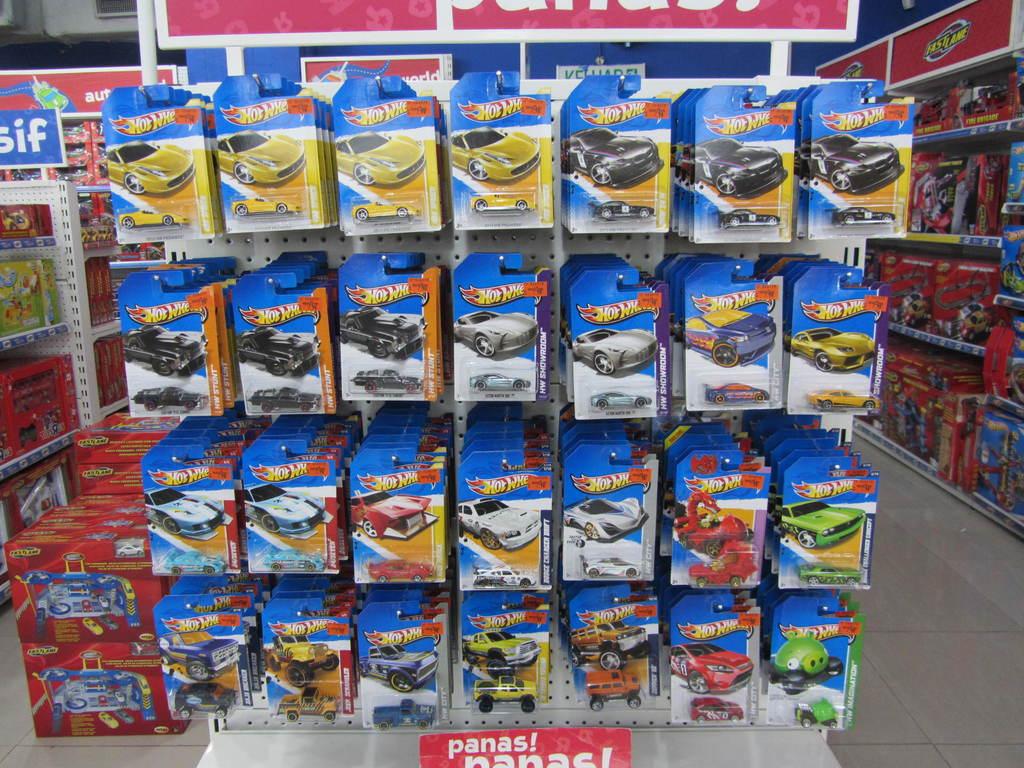What brand of toys are these cars?
Provide a short and direct response. Hot wheels. What is the name of the car on the top right?
Ensure brevity in your answer.  Hot wheels. 